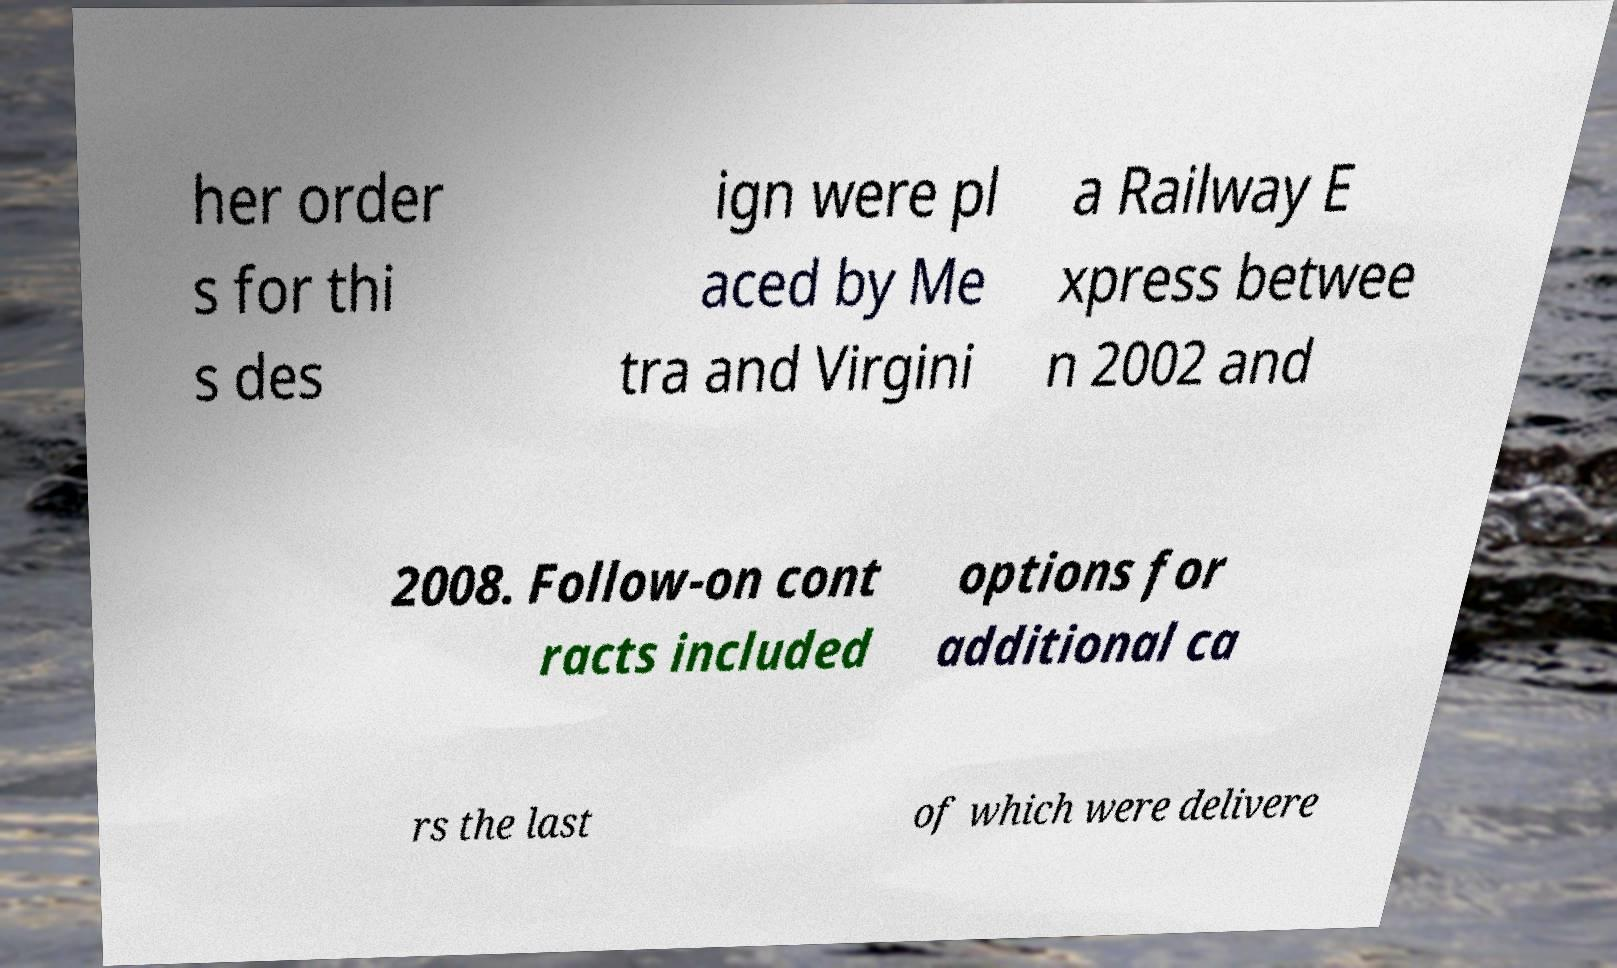What messages or text are displayed in this image? I need them in a readable, typed format. her order s for thi s des ign were pl aced by Me tra and Virgini a Railway E xpress betwee n 2002 and 2008. Follow-on cont racts included options for additional ca rs the last of which were delivere 